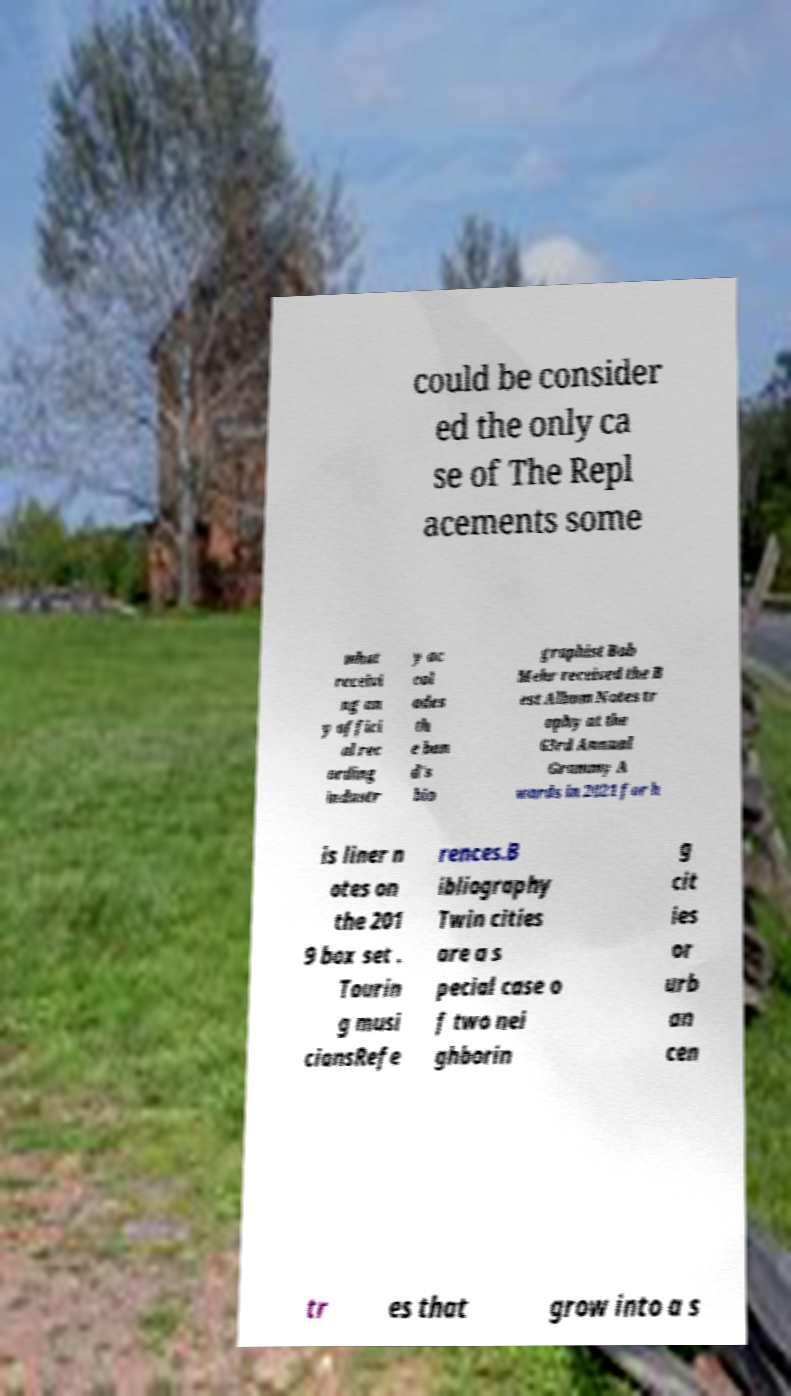Could you assist in decoding the text presented in this image and type it out clearly? could be consider ed the only ca se of The Repl acements some what receivi ng an y offici al rec ording industr y ac col ades th e ban d's bio graphist Bob Mehr received the B est Album Notes tr ophy at the 63rd Annual Grammy A wards in 2021 for h is liner n otes on the 201 9 box set . Tourin g musi ciansRefe rences.B ibliography Twin cities are a s pecial case o f two nei ghborin g cit ies or urb an cen tr es that grow into a s 